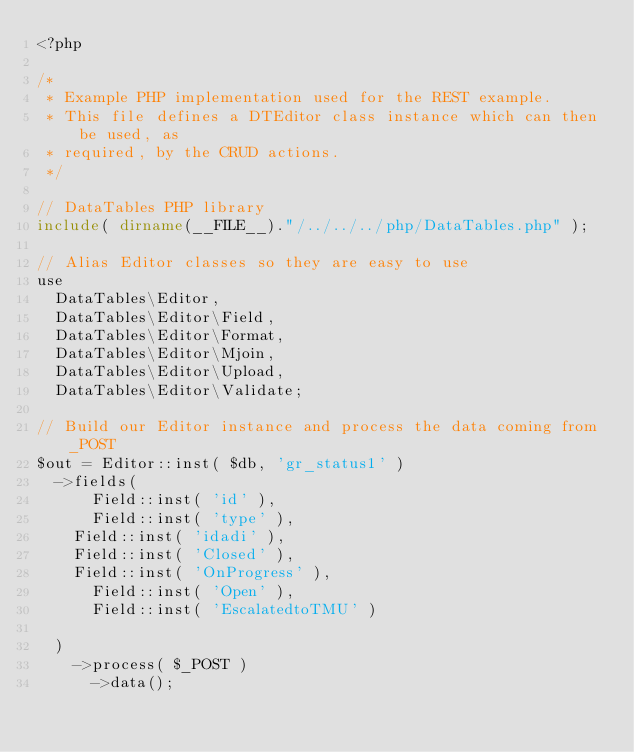<code> <loc_0><loc_0><loc_500><loc_500><_PHP_><?php

/*
 * Example PHP implementation used for the REST example.
 * This file defines a DTEditor class instance which can then be used, as
 * required, by the CRUD actions.
 */

// DataTables PHP library
include( dirname(__FILE__)."/../../../php/DataTables.php" );

// Alias Editor classes so they are easy to use
use
	DataTables\Editor,
	DataTables\Editor\Field,
	DataTables\Editor\Format,
	DataTables\Editor\Mjoin,
	DataTables\Editor\Upload,
	DataTables\Editor\Validate;

// Build our Editor instance and process the data coming from _POST
$out = Editor::inst( $db, 'gr_status1' )
	->fields(
	    Field::inst( 'id' ),
	    Field::inst( 'type' ),
		Field::inst( 'idadi' ),
		Field::inst( 'Closed' ),
		Field::inst( 'OnProgress' ),
	    Field::inst( 'Open' ),
	    Field::inst( 'EscalatedtoTMU' )   
	
	)
		->process( $_POST )
	    ->data();
 </code> 